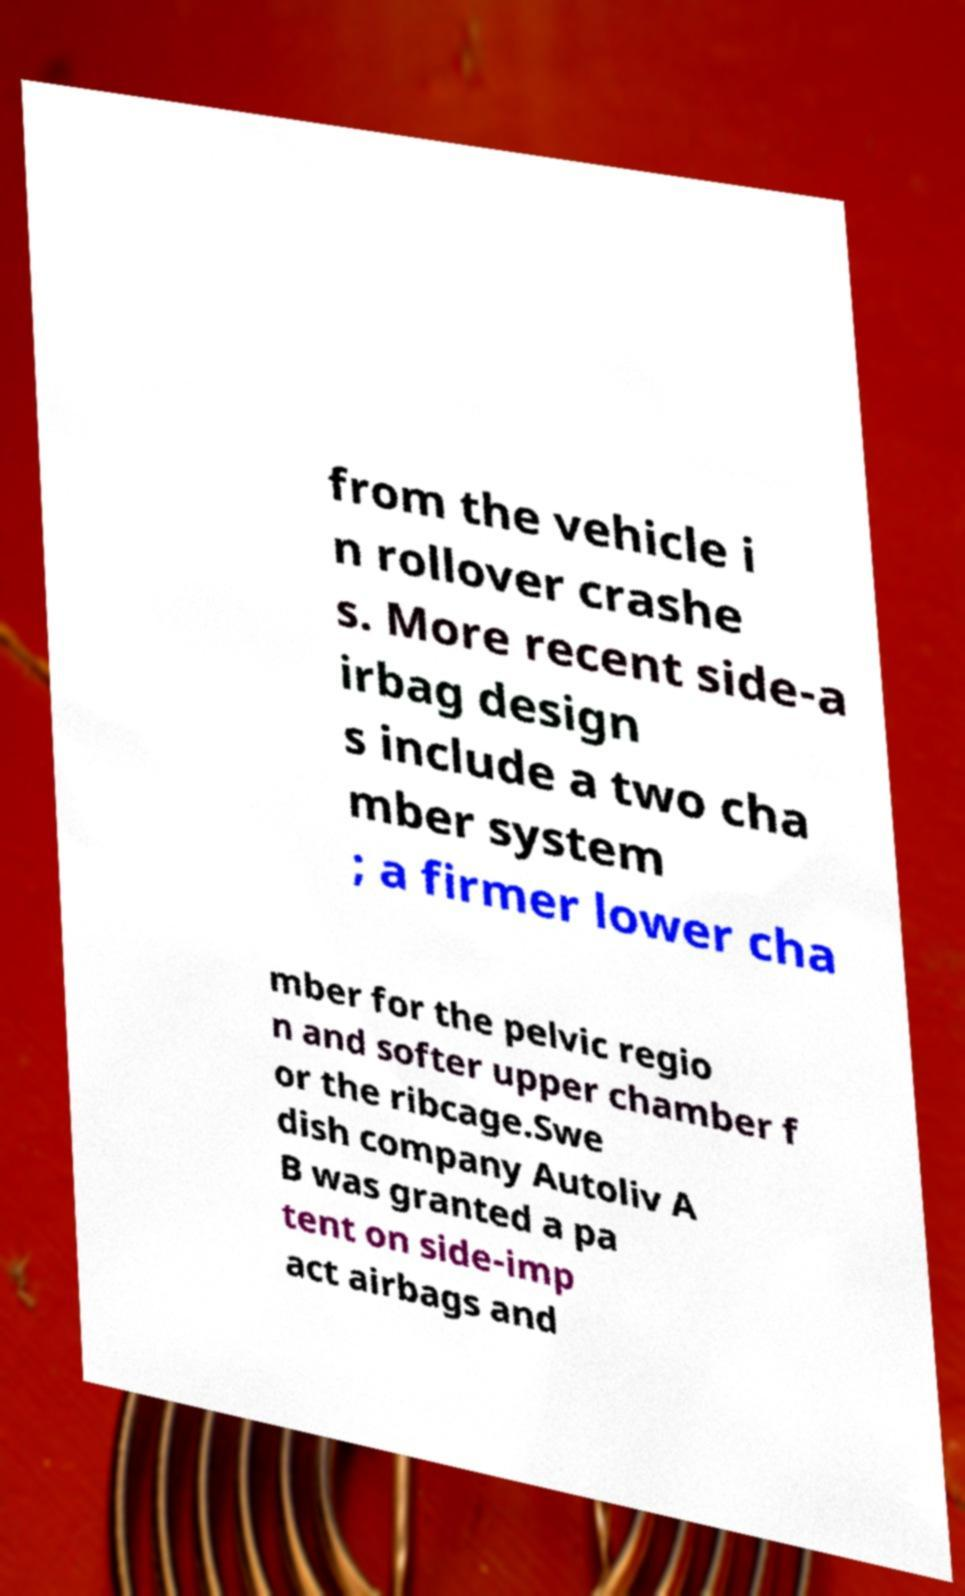There's text embedded in this image that I need extracted. Can you transcribe it verbatim? from the vehicle i n rollover crashe s. More recent side-a irbag design s include a two cha mber system ; a firmer lower cha mber for the pelvic regio n and softer upper chamber f or the ribcage.Swe dish company Autoliv A B was granted a pa tent on side-imp act airbags and 